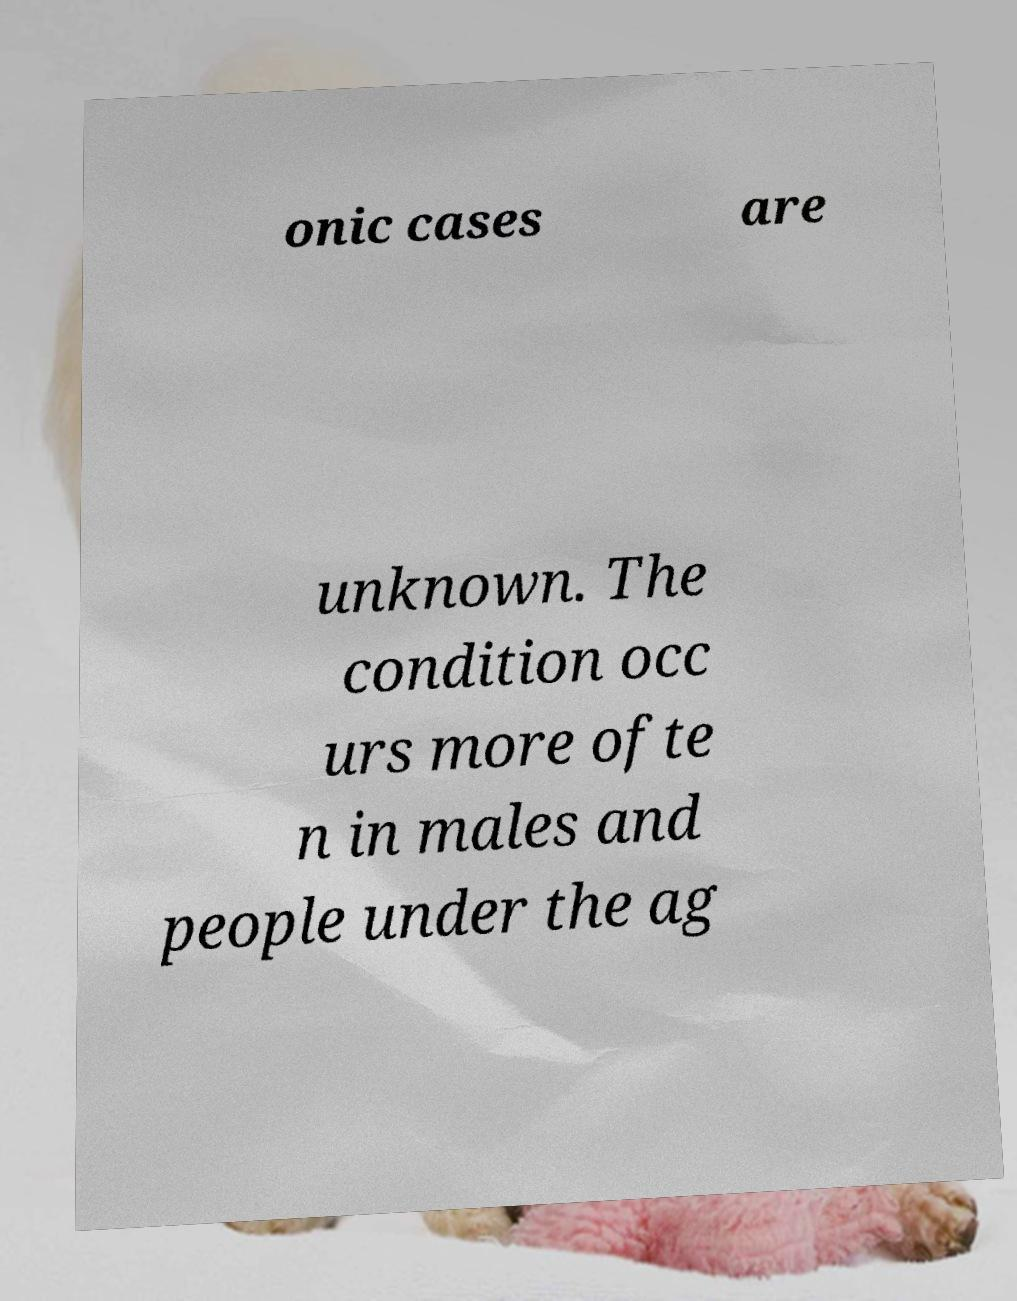Can you read and provide the text displayed in the image?This photo seems to have some interesting text. Can you extract and type it out for me? onic cases are unknown. The condition occ urs more ofte n in males and people under the ag 